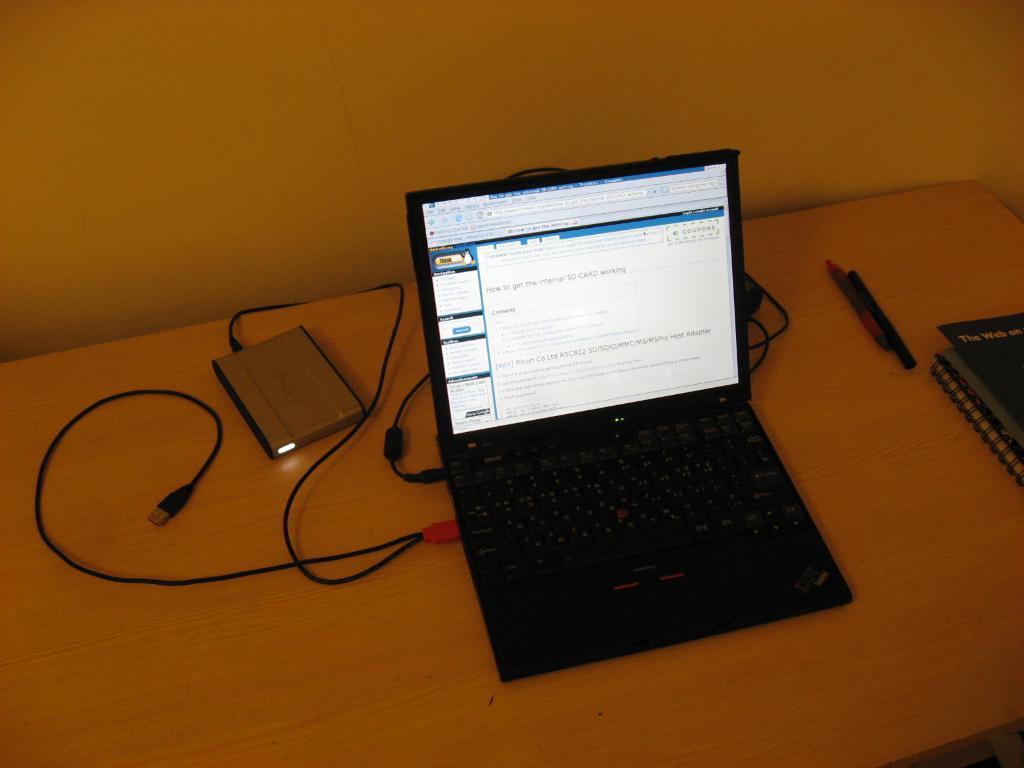Describe this image in one or two sentences. This picture shows a laptop and few books and pens on the table 